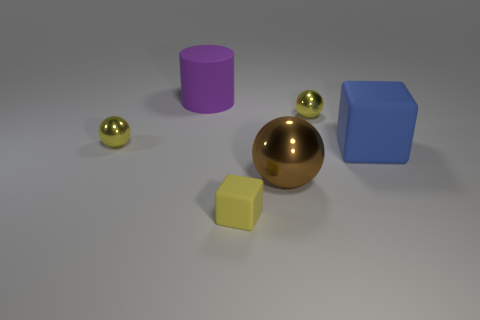Add 1 big purple matte objects. How many objects exist? 7 Subtract all cubes. How many objects are left? 4 Subtract 0 green balls. How many objects are left? 6 Subtract all cylinders. Subtract all small brown balls. How many objects are left? 5 Add 6 blue matte things. How many blue matte things are left? 7 Add 5 matte blocks. How many matte blocks exist? 7 